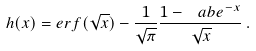Convert formula to latex. <formula><loc_0><loc_0><loc_500><loc_500>h ( x ) = e r f ( \sqrt { x } ) - \frac { 1 } { \sqrt { \pi } } \frac { 1 - \ a b { e } ^ { - x } } { \sqrt { x } } \, .</formula> 